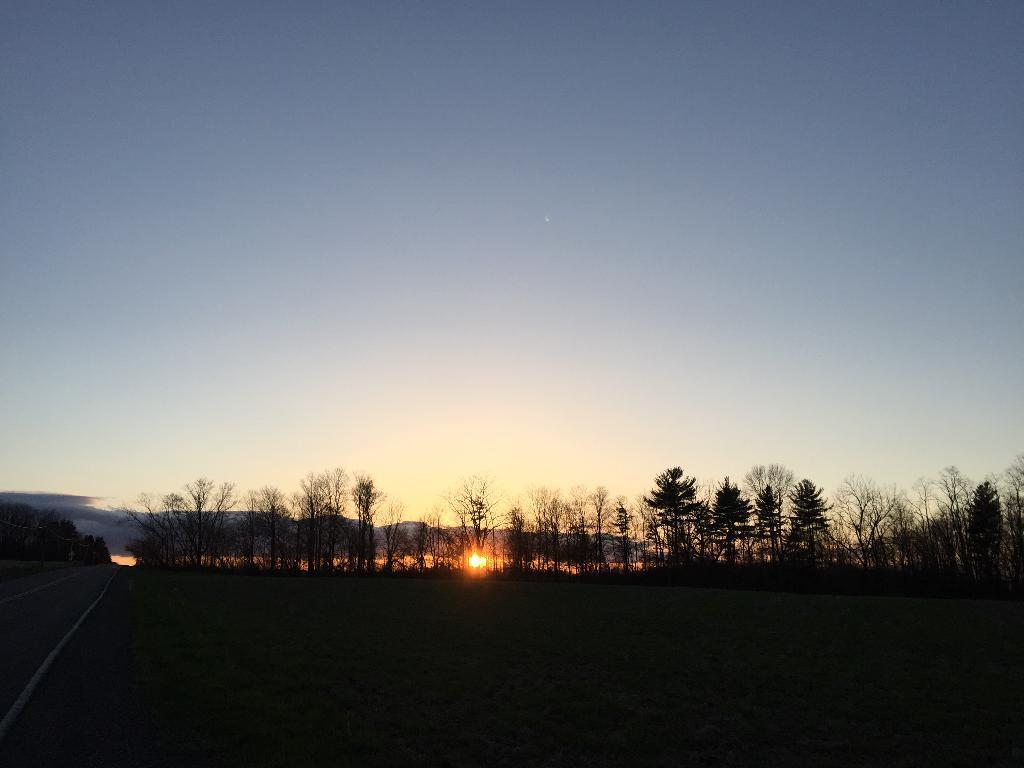How would you summarize this image in a sentence or two? In this image we can see there is a grass, road, trees, mountains and the sky. 